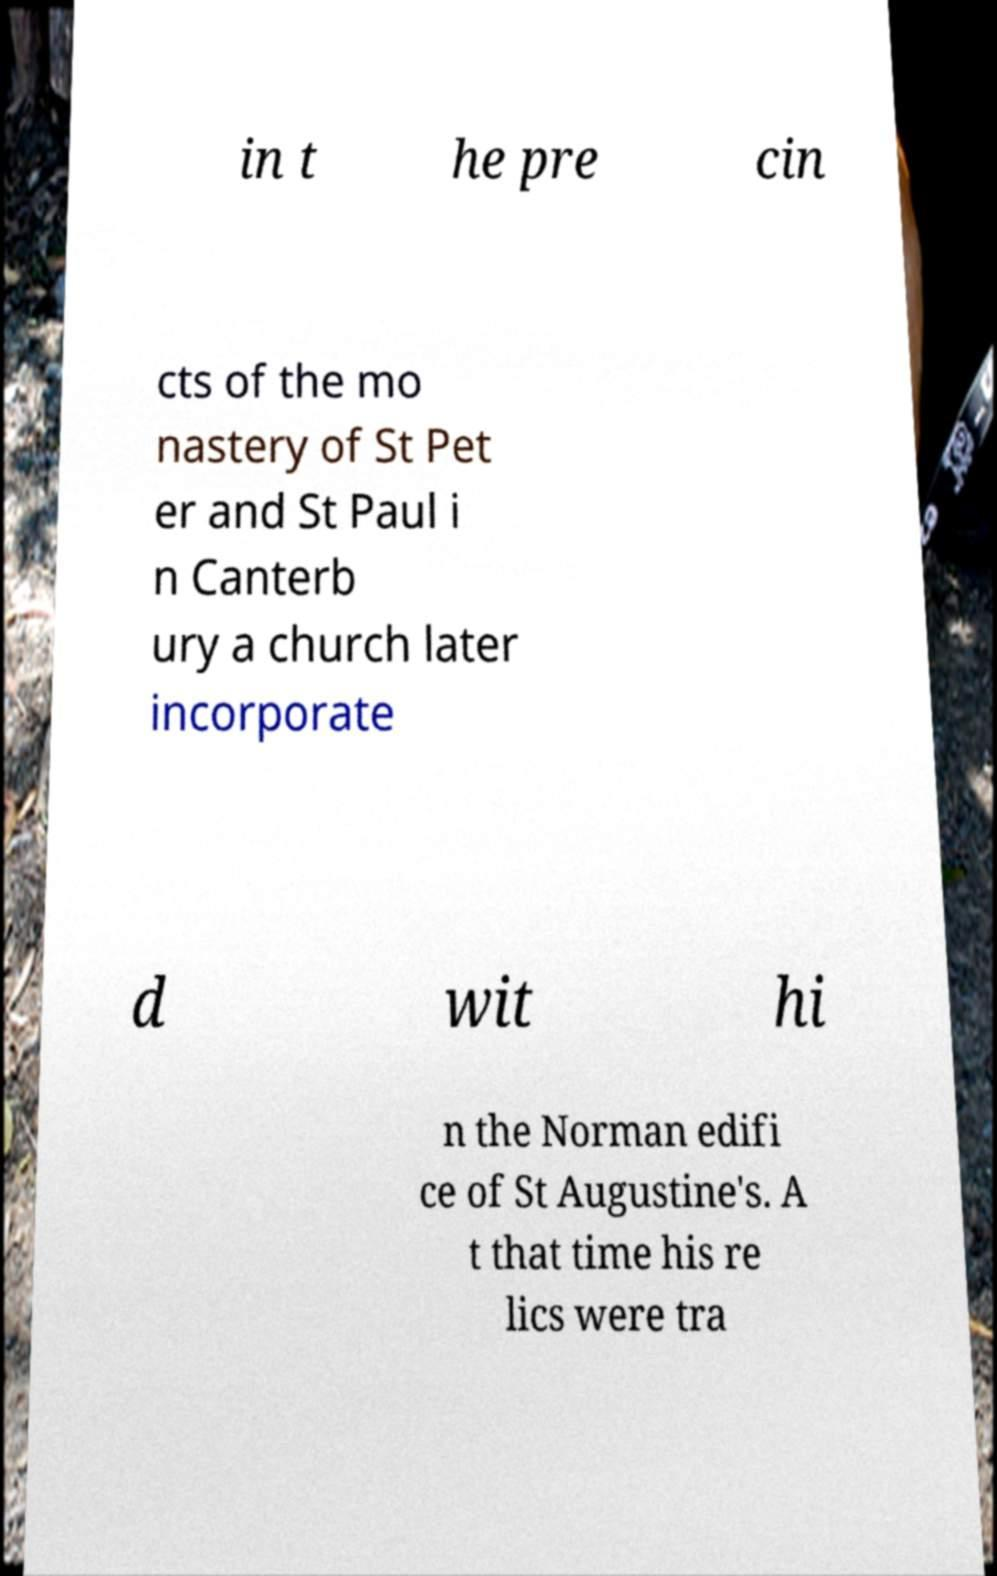Please identify and transcribe the text found in this image. in t he pre cin cts of the mo nastery of St Pet er and St Paul i n Canterb ury a church later incorporate d wit hi n the Norman edifi ce of St Augustine's. A t that time his re lics were tra 